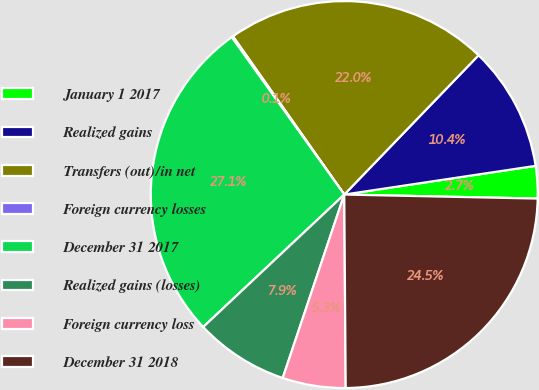Convert chart to OTSL. <chart><loc_0><loc_0><loc_500><loc_500><pie_chart><fcel>January 1 2017<fcel>Realized gains<fcel>Transfers (out)/in net<fcel>Foreign currency losses<fcel>December 31 2017<fcel>Realized gains (losses)<fcel>Foreign currency loss<fcel>December 31 2018<nl><fcel>2.7%<fcel>10.42%<fcel>21.97%<fcel>0.12%<fcel>27.12%<fcel>7.85%<fcel>5.27%<fcel>24.55%<nl></chart> 